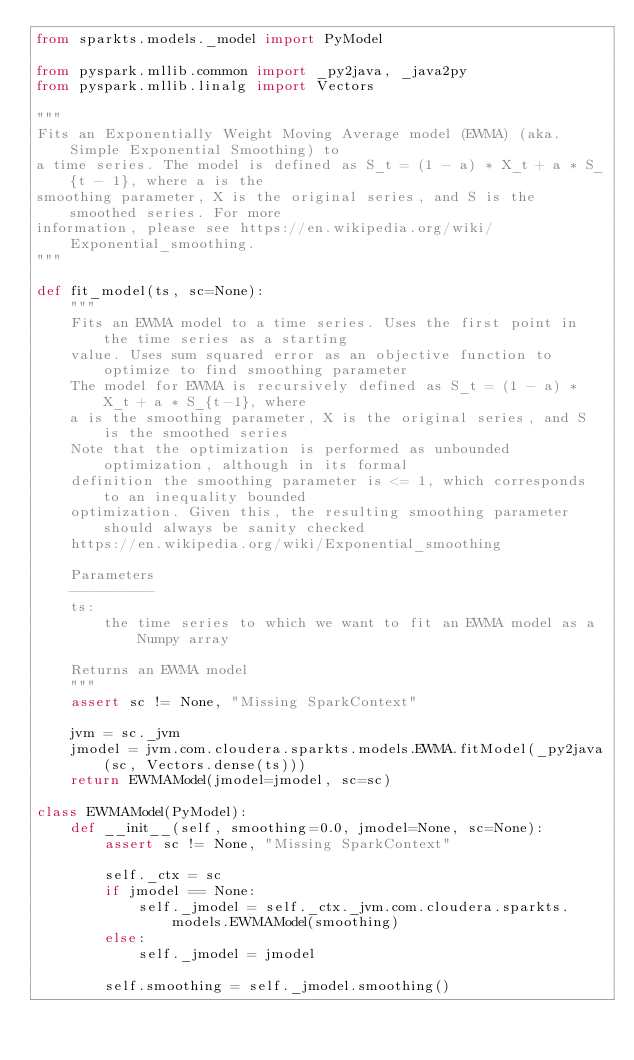<code> <loc_0><loc_0><loc_500><loc_500><_Python_>from sparkts.models._model import PyModel

from pyspark.mllib.common import _py2java, _java2py
from pyspark.mllib.linalg import Vectors

"""
Fits an Exponentially Weight Moving Average model (EWMA) (aka. Simple Exponential Smoothing) to
a time series. The model is defined as S_t = (1 - a) * X_t + a * S_{t - 1}, where a is the
smoothing parameter, X is the original series, and S is the smoothed series. For more
information, please see https://en.wikipedia.org/wiki/Exponential_smoothing.
"""

def fit_model(ts, sc=None):
    """
    Fits an EWMA model to a time series. Uses the first point in the time series as a starting
    value. Uses sum squared error as an objective function to optimize to find smoothing parameter
    The model for EWMA is recursively defined as S_t = (1 - a) * X_t + a * S_{t-1}, where
    a is the smoothing parameter, X is the original series, and S is the smoothed series
    Note that the optimization is performed as unbounded optimization, although in its formal
    definition the smoothing parameter is <= 1, which corresponds to an inequality bounded
    optimization. Given this, the resulting smoothing parameter should always be sanity checked
    https://en.wikipedia.org/wiki/Exponential_smoothing
    
    Parameters
    ----------
    ts:
        the time series to which we want to fit an EWMA model as a Numpy array
        
    Returns an EWMA model
    """
    assert sc != None, "Missing SparkContext"

    jvm = sc._jvm
    jmodel = jvm.com.cloudera.sparkts.models.EWMA.fitModel(_py2java(sc, Vectors.dense(ts)))
    return EWMAModel(jmodel=jmodel, sc=sc)

class EWMAModel(PyModel):
    def __init__(self, smoothing=0.0, jmodel=None, sc=None):
        assert sc != None, "Missing SparkContext"
        
        self._ctx = sc
        if jmodel == None:
            self._jmodel = self._ctx._jvm.com.cloudera.sparkts.models.EWMAModel(smoothing)
        else:
            self._jmodel = jmodel
        
        self.smoothing = self._jmodel.smoothing()
</code> 